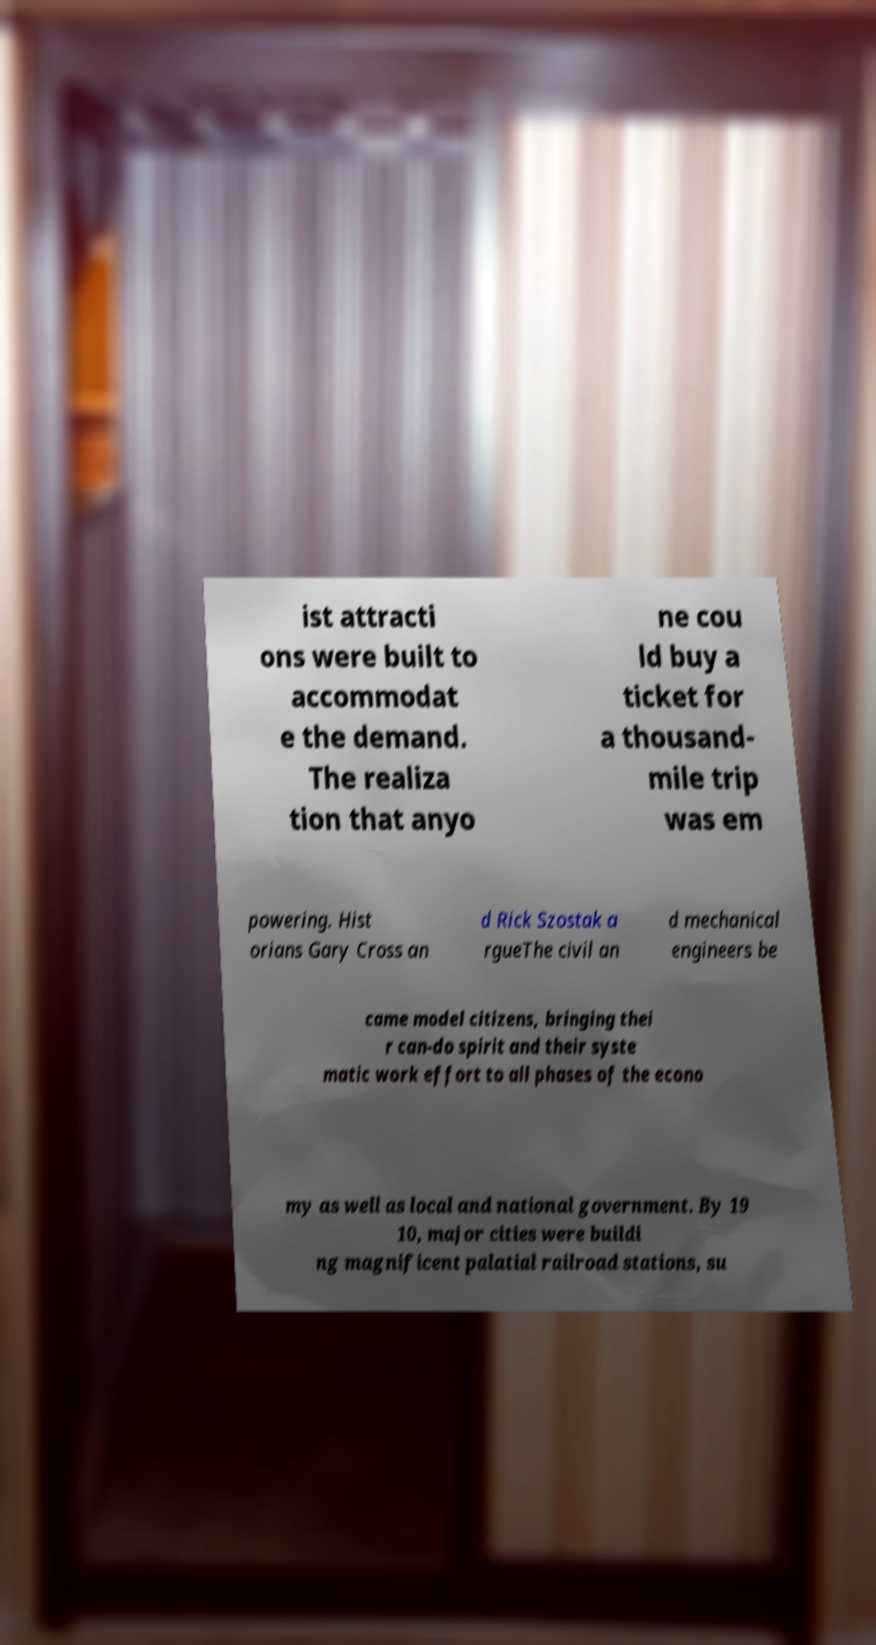For documentation purposes, I need the text within this image transcribed. Could you provide that? ist attracti ons were built to accommodat e the demand. The realiza tion that anyo ne cou ld buy a ticket for a thousand- mile trip was em powering. Hist orians Gary Cross an d Rick Szostak a rgueThe civil an d mechanical engineers be came model citizens, bringing thei r can-do spirit and their syste matic work effort to all phases of the econo my as well as local and national government. By 19 10, major cities were buildi ng magnificent palatial railroad stations, su 